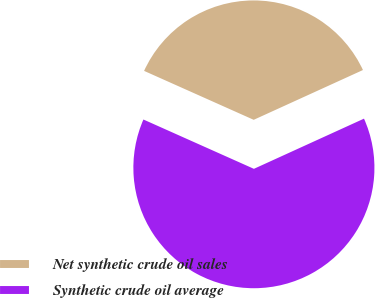<chart> <loc_0><loc_0><loc_500><loc_500><pie_chart><fcel>Net synthetic crude oil sales<fcel>Synthetic crude oil average<nl><fcel>36.51%<fcel>63.49%<nl></chart> 